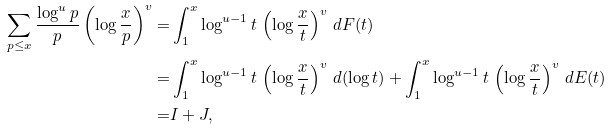Convert formula to latex. <formula><loc_0><loc_0><loc_500><loc_500>\sum _ { p \leq x } \frac { \log ^ { u } p } p \left ( \log \frac { x } { p } \right ) ^ { v } = & \int _ { 1 } ^ { x } \log ^ { u - 1 } t \, \left ( \log \frac { x } { t } \right ) ^ { v } \, d F ( t ) \\ = & \int _ { 1 } ^ { x } \log ^ { u - 1 } t \, \left ( \log \frac { x } { t } \right ) ^ { v } \, d ( \log t ) + \int _ { 1 } ^ { x } \log ^ { u - 1 } t \, \left ( \log \frac { x } { t } \right ) ^ { v } \, d E ( t ) \\ = & I + J ,</formula> 